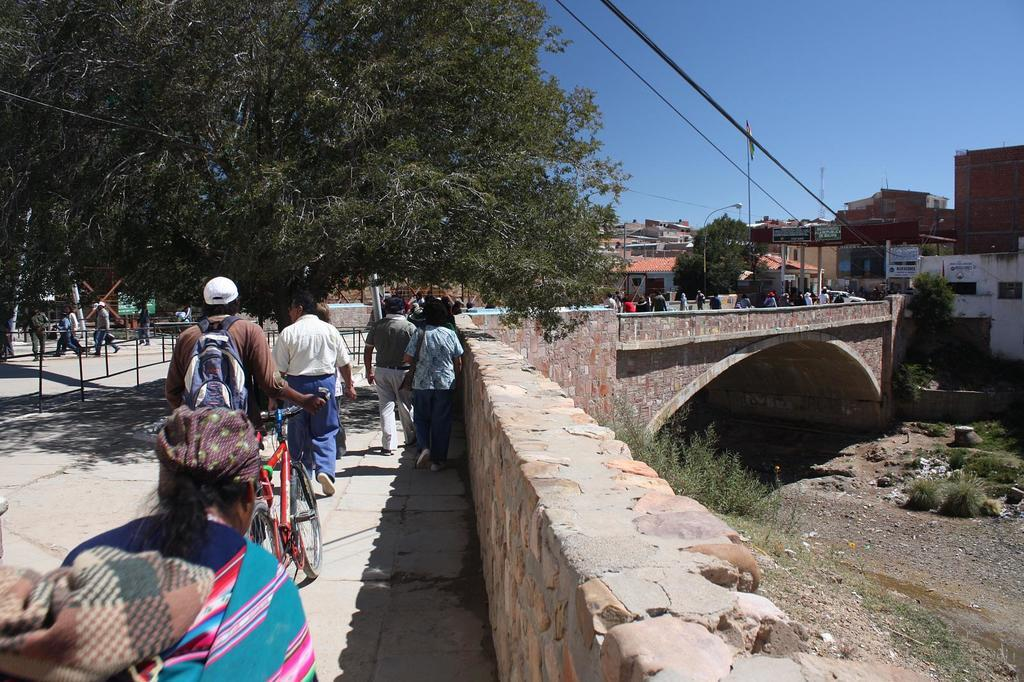How many people are in the image? There is a group of people in the image, but the exact number is not specified. What is on the ground near the group of people? There is a bicycle on the ground in the image. What can be seen in the distance behind the group of people? In the background of the image, there is a bridge, vehicles, buildings, trees, poles, and the sky. Can you describe the objects that are not specified in the background? Unfortunately, the provided facts do not give any details about the unspecified objects in the background. What type of bells can be heard ringing in the image? There is no mention of bells or any sounds in the image, so it is not possible to determine if any bells are ringing. 